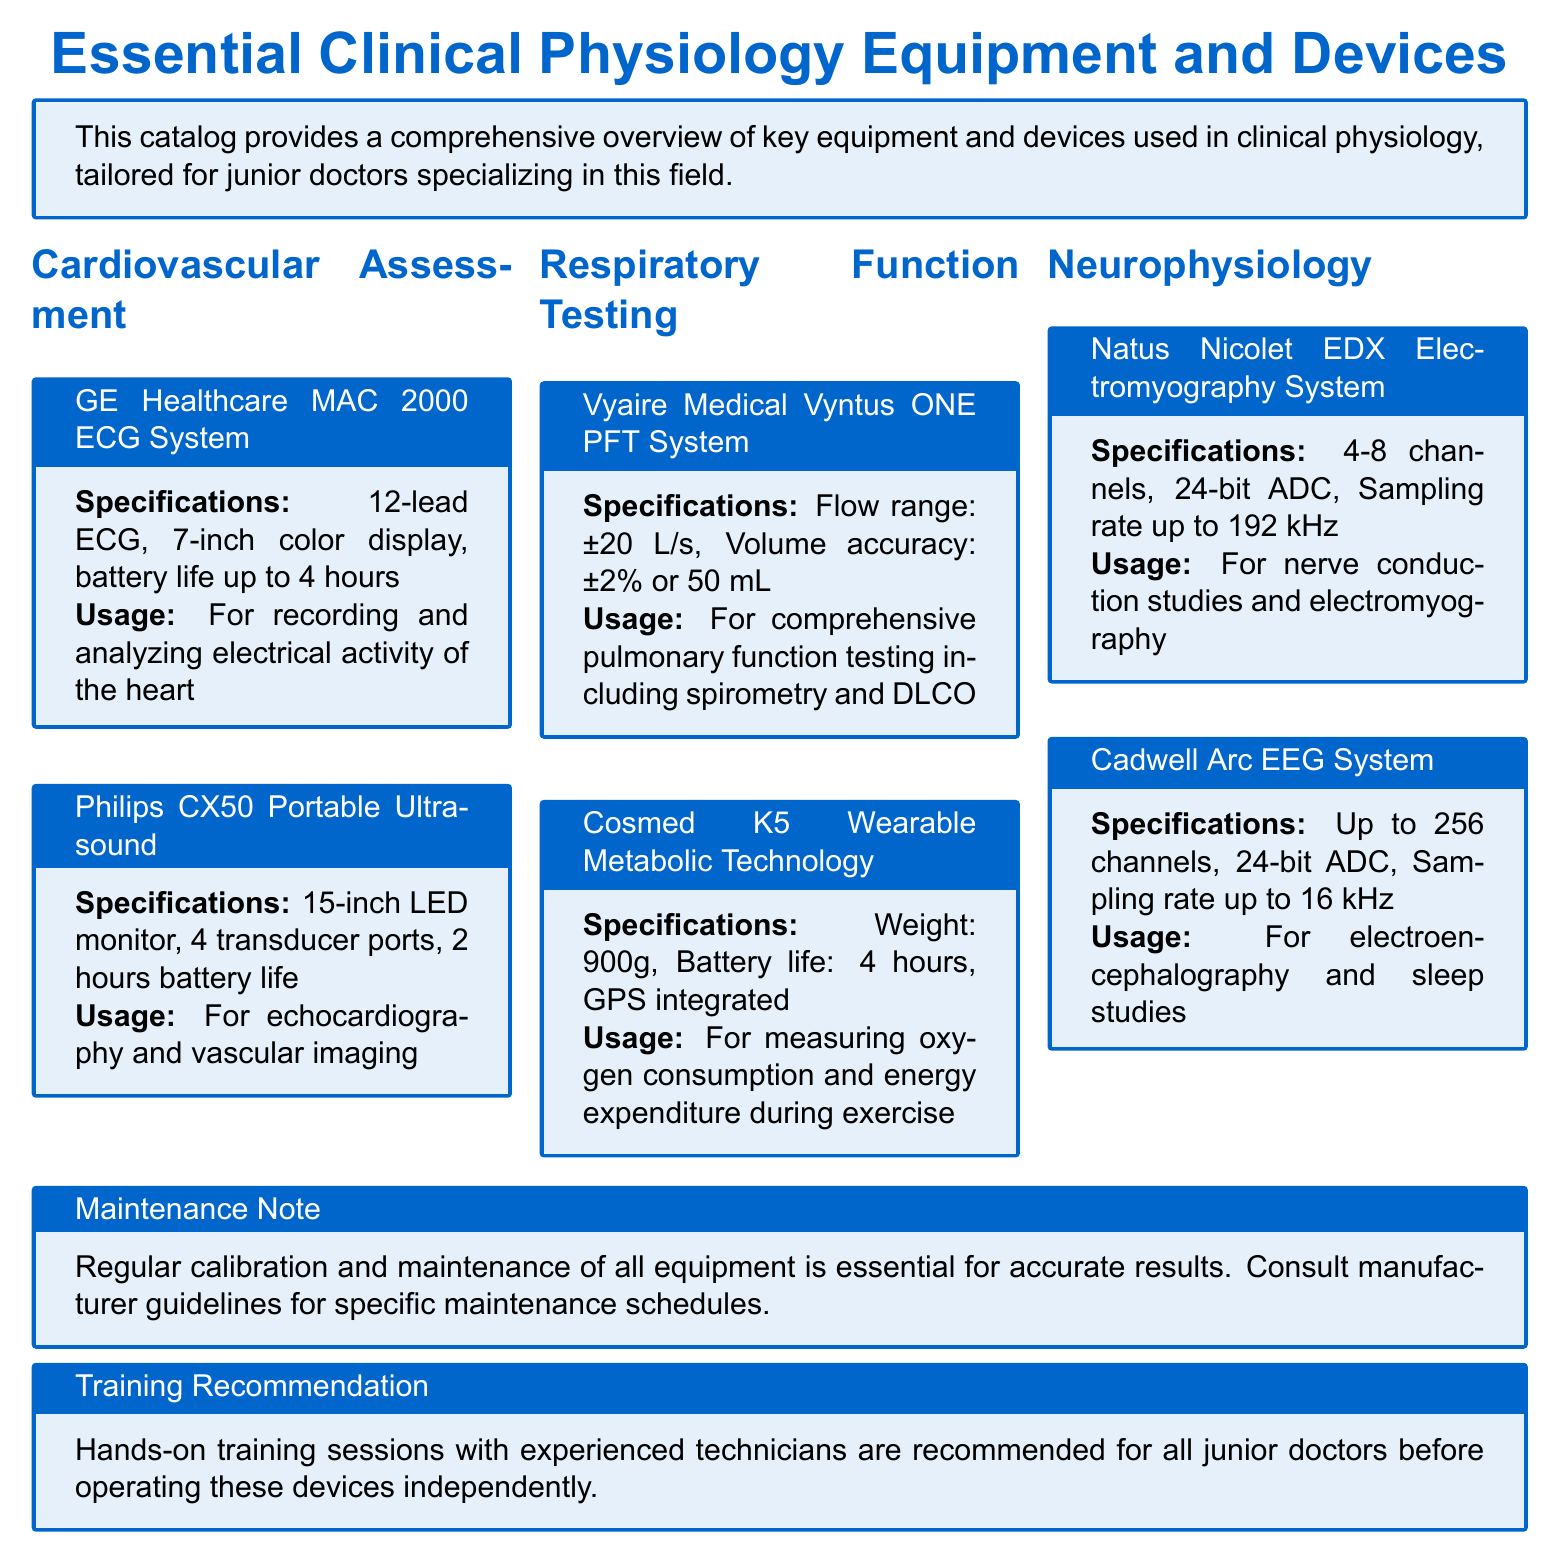What is the display size of the GE Healthcare MAC 2000 ECG System? The display size of the GE Healthcare MAC 2000 ECG System is specified as 7-inch.
Answer: 7-inch What is the battery life of the Philips CX50 Portable Ultrasound? The document states that the battery life of the Philips CX50 Portable Ultrasound is up to 2 hours.
Answer: 2 hours How many channels does the Cadwell Arc EEG System support? The text indicates that the Cadwell Arc EEG System can support up to 256 channels.
Answer: 256 channels What important step is highlighted in the Maintenance Note? The Maintenance Note emphasizes the importance of regular calibration and maintenance of all equipment.
Answer: Regular calibration and maintenance What type of testing does the Vyaire Medical Vyntus ONE PFT System perform? The Vyaire Medical Vyntus ONE PFT System is used for comprehensive pulmonary function testing including spirometry.
Answer: Comprehensive pulmonary function testing Which device is used for measuring energy expenditure during exercise? The device used for measuring energy expenditure during exercise is the Cosmed K5 Wearable Metabolic Technology.
Answer: Cosmed K5 Wearable Metabolic Technology What is recommended before operating devices independently? The document recommends hands-on training sessions with experienced technicians before operating devices independently.
Answer: Hands-on training sessions What specification does the Natus Nicolet EDX Electromyography System have? The Natus Nicolet EDX Electromyography System has a 24-bit ADC as part of its specifications.
Answer: 24-bit ADC What is the flow range of the Vyaire Medical Vyntus ONE PFT System? The flow range specified for the Vyaire Medical Vyntus ONE PFT System is ±20 L/s.
Answer: ±20 L/s 